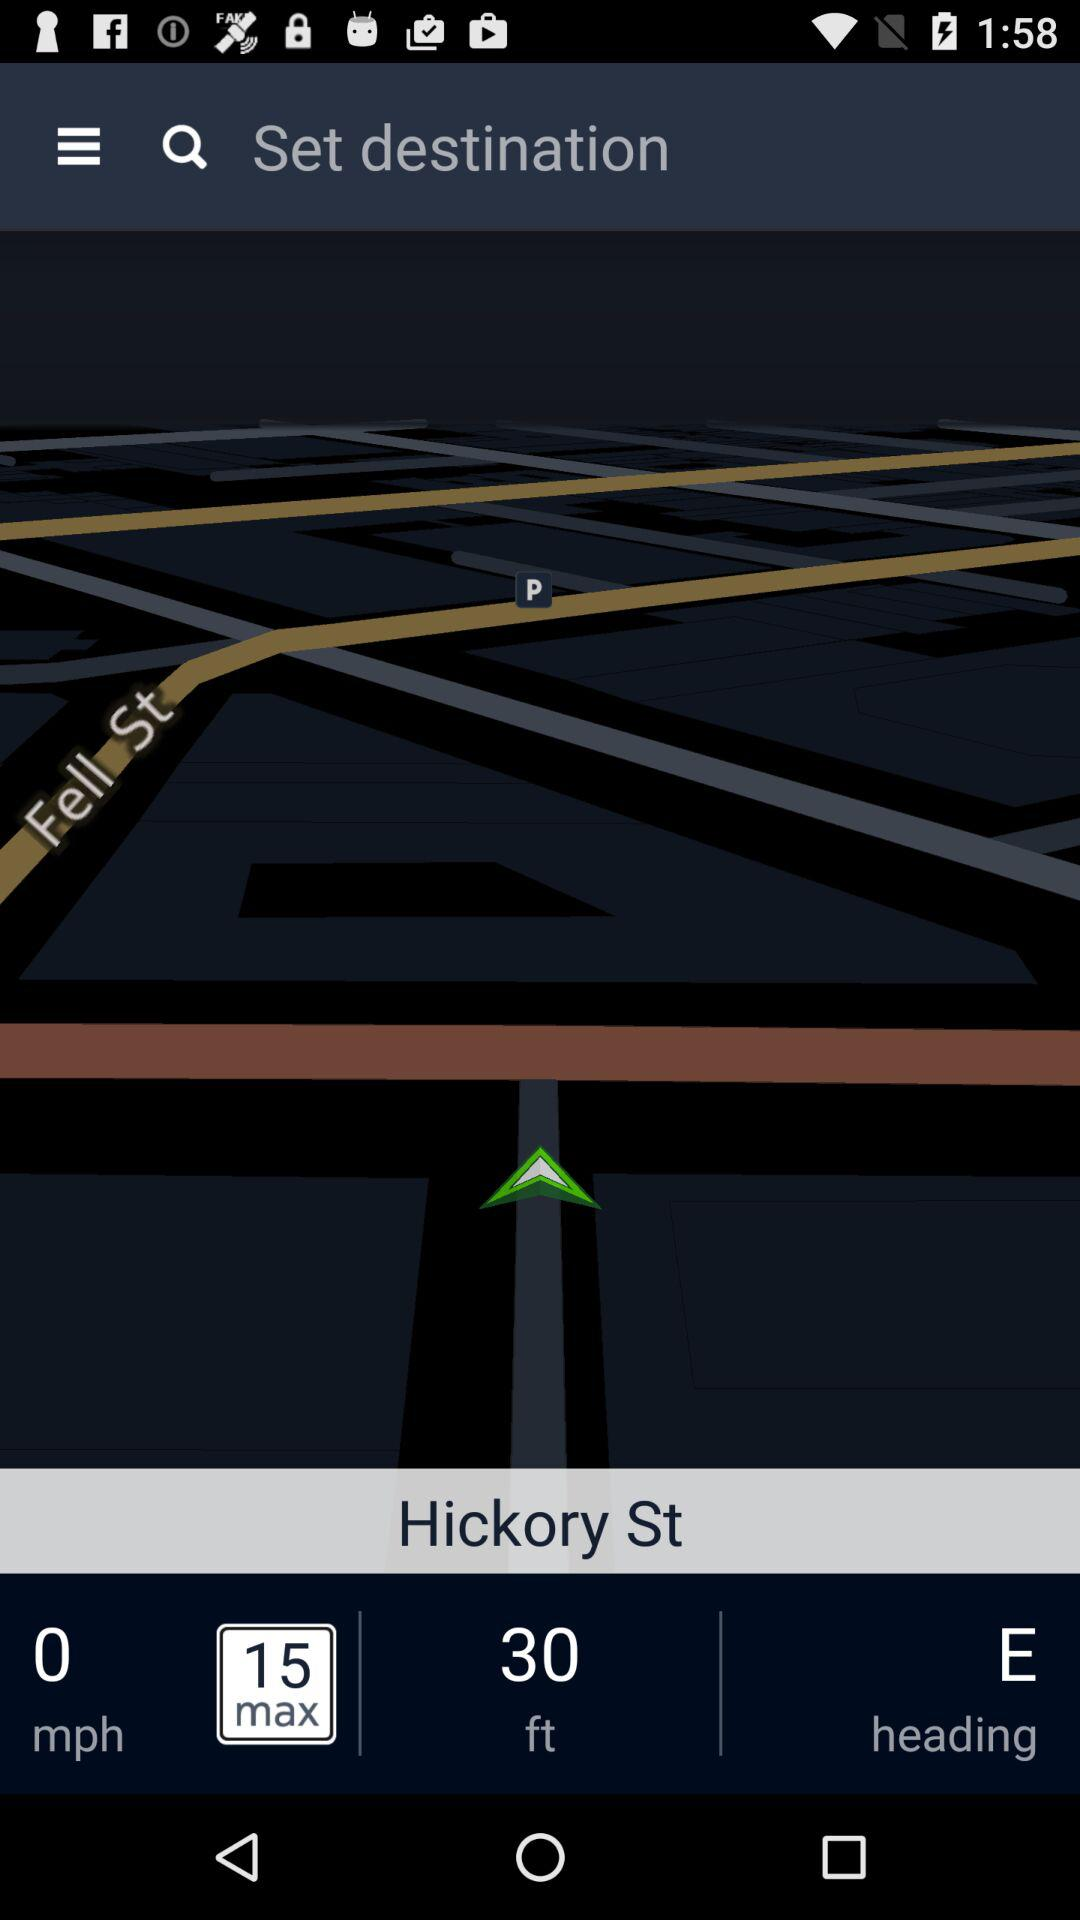How many feet are there? There are 30 feet. 